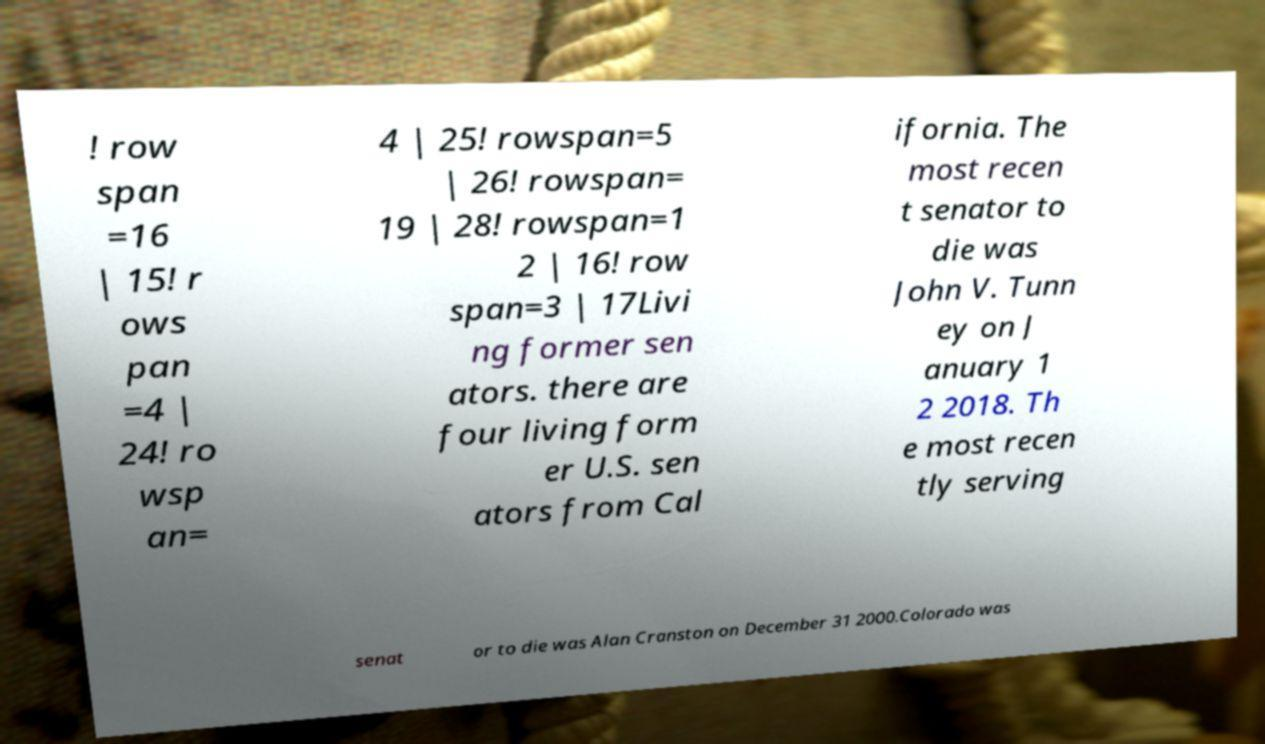For documentation purposes, I need the text within this image transcribed. Could you provide that? ! row span =16 | 15! r ows pan =4 | 24! ro wsp an= 4 | 25! rowspan=5 | 26! rowspan= 19 | 28! rowspan=1 2 | 16! row span=3 | 17Livi ng former sen ators. there are four living form er U.S. sen ators from Cal ifornia. The most recen t senator to die was John V. Tunn ey on J anuary 1 2 2018. Th e most recen tly serving senat or to die was Alan Cranston on December 31 2000.Colorado was 